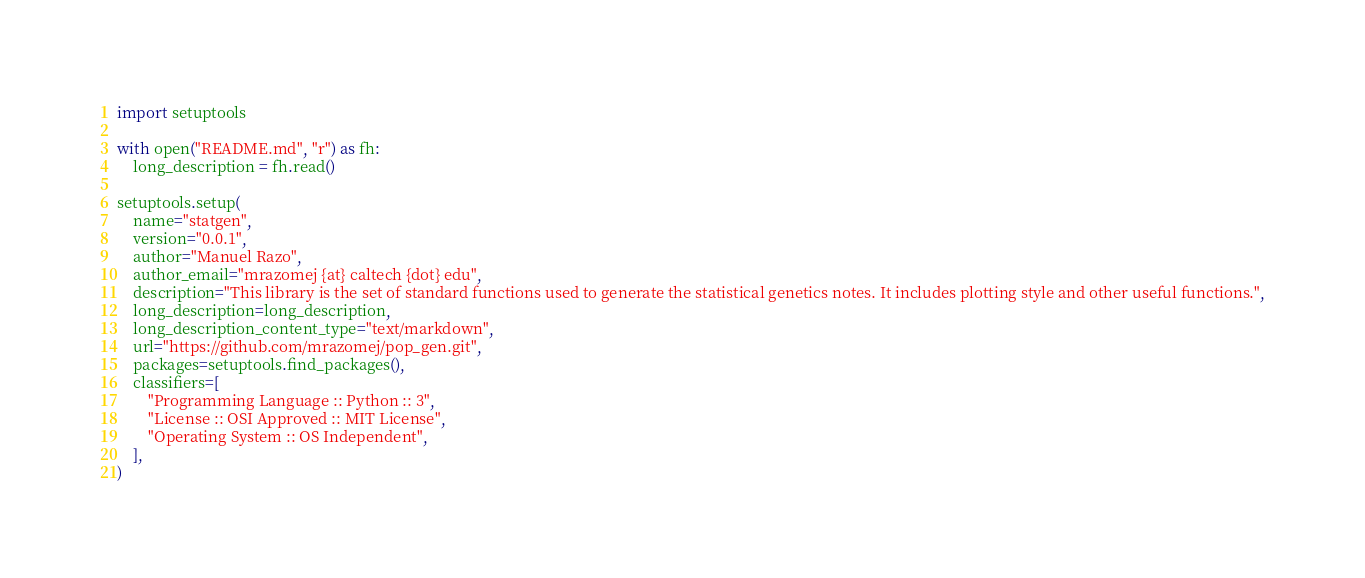<code> <loc_0><loc_0><loc_500><loc_500><_Python_>import setuptools

with open("README.md", "r") as fh:
    long_description = fh.read()

setuptools.setup(
    name="statgen",
    version="0.0.1",
    author="Manuel Razo",
    author_email="mrazomej {at} caltech {dot} edu",
    description="This library is the set of standard functions used to generate the statistical genetics notes. It includes plotting style and other useful functions.",
    long_description=long_description,
    long_description_content_type="text/markdown",
    url="https://github.com/mrazomej/pop_gen.git",
    packages=setuptools.find_packages(),
    classifiers=[
        "Programming Language :: Python :: 3",
        "License :: OSI Approved :: MIT License",
        "Operating System :: OS Independent",
    ],
)
</code> 